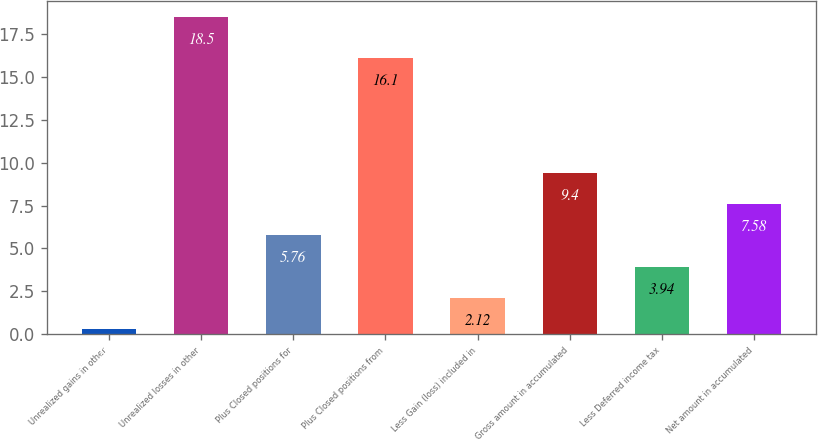Convert chart to OTSL. <chart><loc_0><loc_0><loc_500><loc_500><bar_chart><fcel>Unrealized gains in other<fcel>Unrealized losses in other<fcel>Plus Closed positions for<fcel>Plus Closed positions from<fcel>Less Gain (loss) included in<fcel>Gross amount in accumulated<fcel>Less Deferred income tax<fcel>Net amount in accumulated<nl><fcel>0.3<fcel>18.5<fcel>5.76<fcel>16.1<fcel>2.12<fcel>9.4<fcel>3.94<fcel>7.58<nl></chart> 